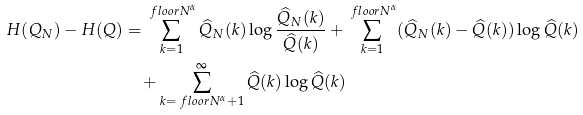<formula> <loc_0><loc_0><loc_500><loc_500>H ( Q _ { N } ) - H ( Q ) & = \sum _ { k = 1 } ^ { \ f l o o r { N ^ { \alpha } } } \widehat { Q } _ { N } ( k ) \log \frac { \widehat { Q } _ { N } ( k ) } { \widehat { Q } ( k ) } + \sum _ { k = 1 } ^ { \ f l o o r { N ^ { \alpha } } } ( \widehat { Q } _ { N } ( k ) - \widehat { Q } ( k ) ) \log \widehat { Q } ( k ) \\ & \quad + \sum _ { k = \ f l o o r { N ^ { \alpha } } + 1 } ^ { \infty } \widehat { Q } ( k ) \log \widehat { Q } ( k )</formula> 